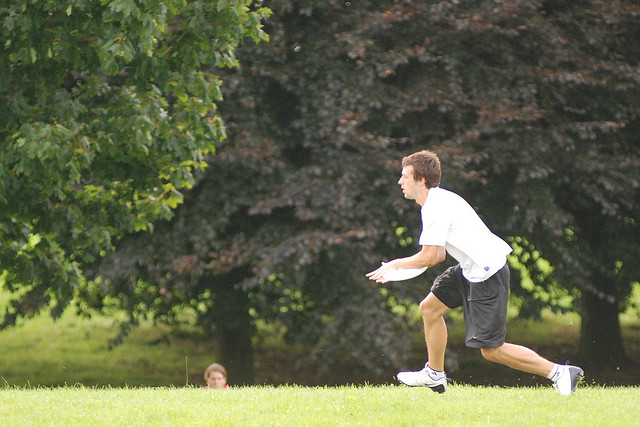How many trees are there? In the image, we can see an expansive green area with several trees. The most prominent ones in the foreground are two large trees with lush canopies, possibly oak or maple, providing ample shade. However, given the perspective, there might be additional trees further in the background or just out of the frame that are not clearly visible. 